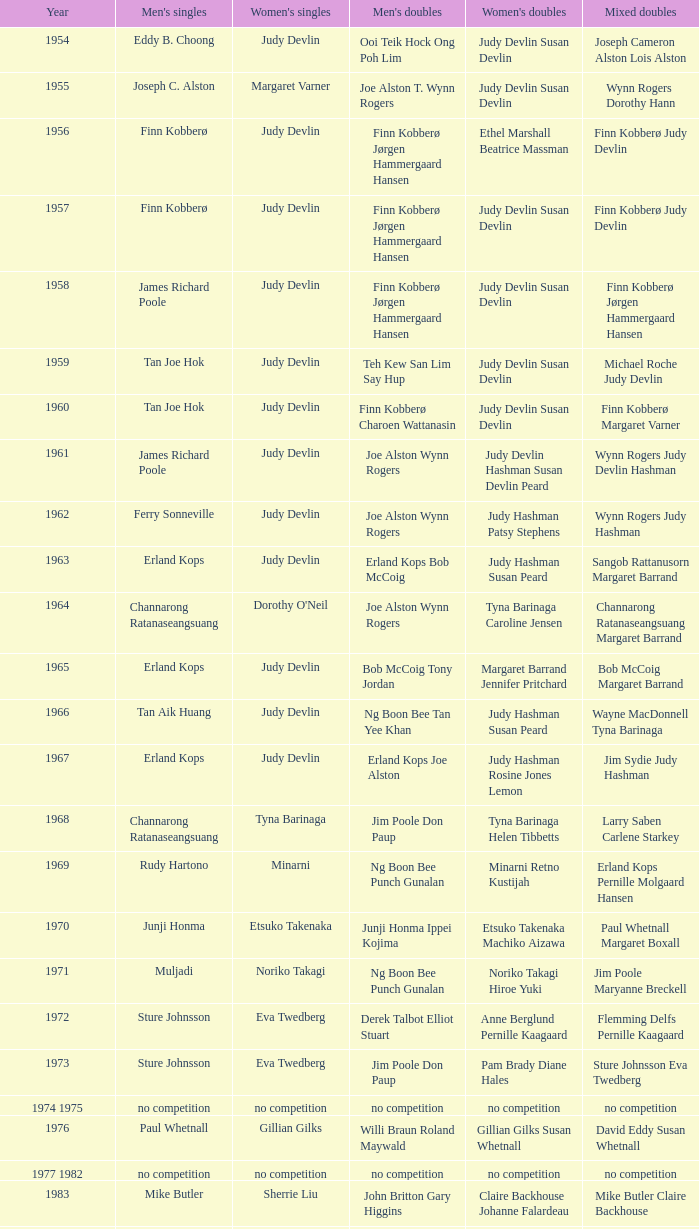Who claimed the title of women's singles champion in 1984? Luo Yun. 